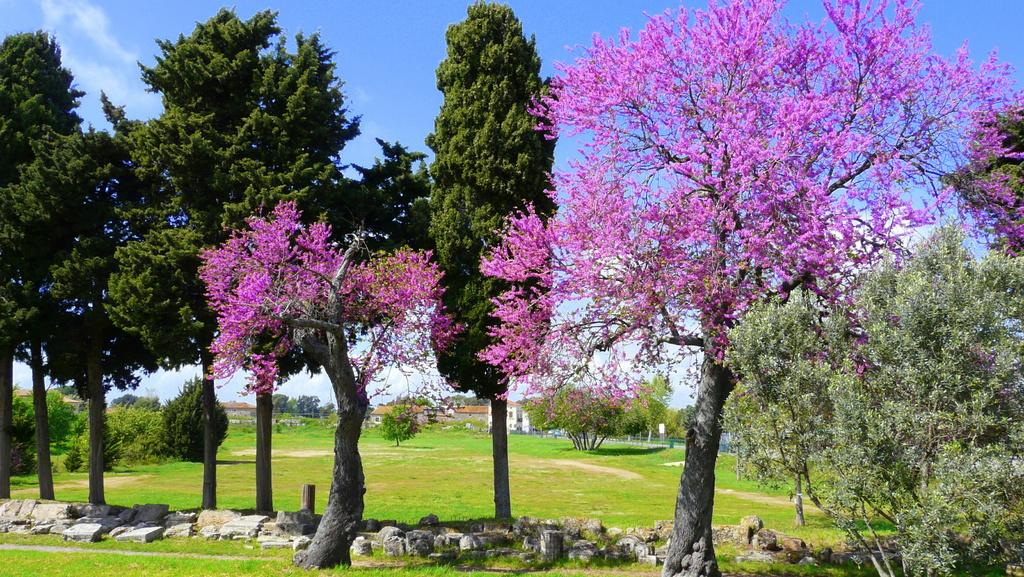What type of vegetation is present in the image? There are trees in the image. What other natural elements can be seen in the image? There are rocks in the image. What type of man-made structures are visible in the image? There are buildings in the image. What is the surface of the ground like in the image? There is grass on the surface in the image. What type of yam is being served in the image? There is no yam present in the image; it features trees, rocks, buildings, and grass. What emotion is being expressed by the trees in the image? Trees do not express emotions; they are inanimate objects. 